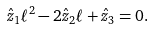<formula> <loc_0><loc_0><loc_500><loc_500>\hat { z } _ { 1 } \ell ^ { 2 } - 2 \hat { z } _ { 2 } \ell + \hat { z } _ { 3 } = 0 .</formula> 